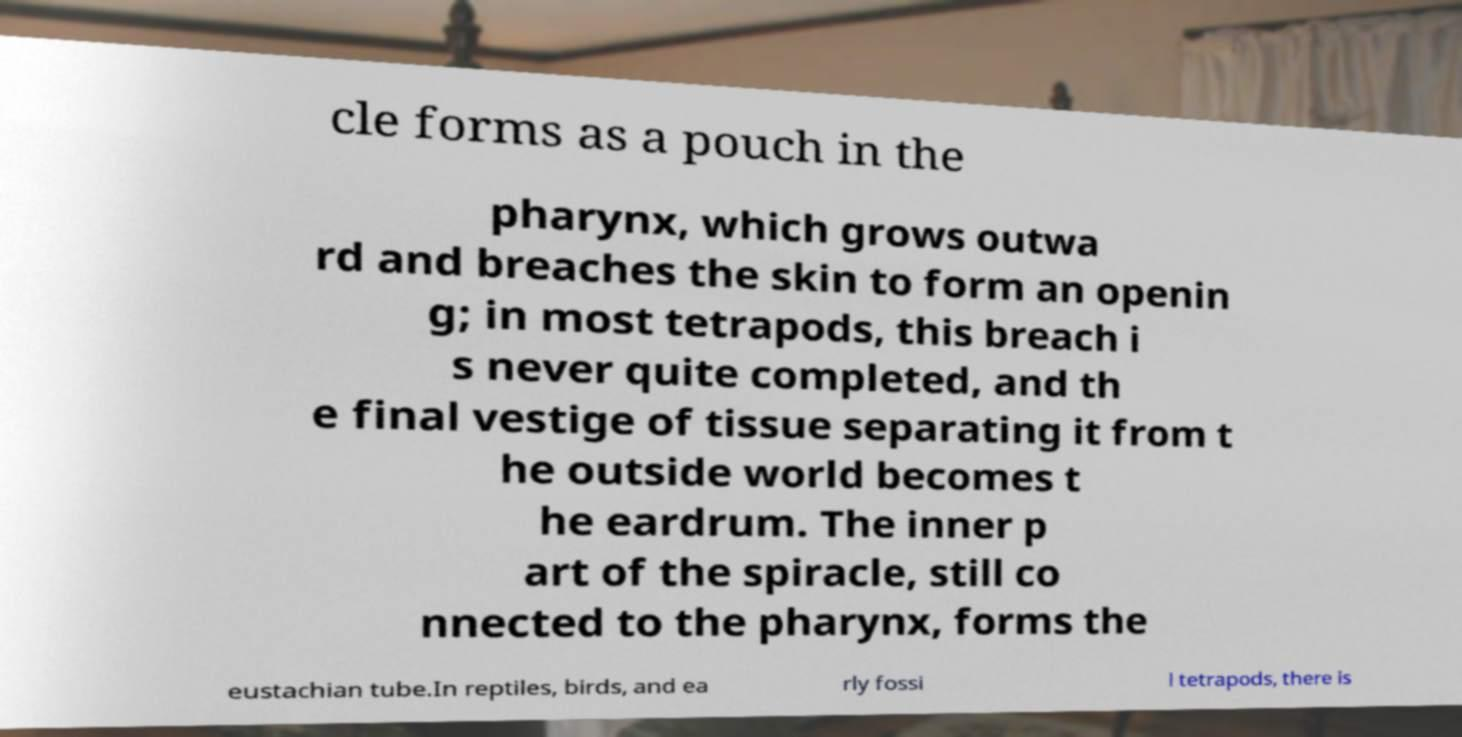Can you accurately transcribe the text from the provided image for me? cle forms as a pouch in the pharynx, which grows outwa rd and breaches the skin to form an openin g; in most tetrapods, this breach i s never quite completed, and th e final vestige of tissue separating it from t he outside world becomes t he eardrum. The inner p art of the spiracle, still co nnected to the pharynx, forms the eustachian tube.In reptiles, birds, and ea rly fossi l tetrapods, there is 